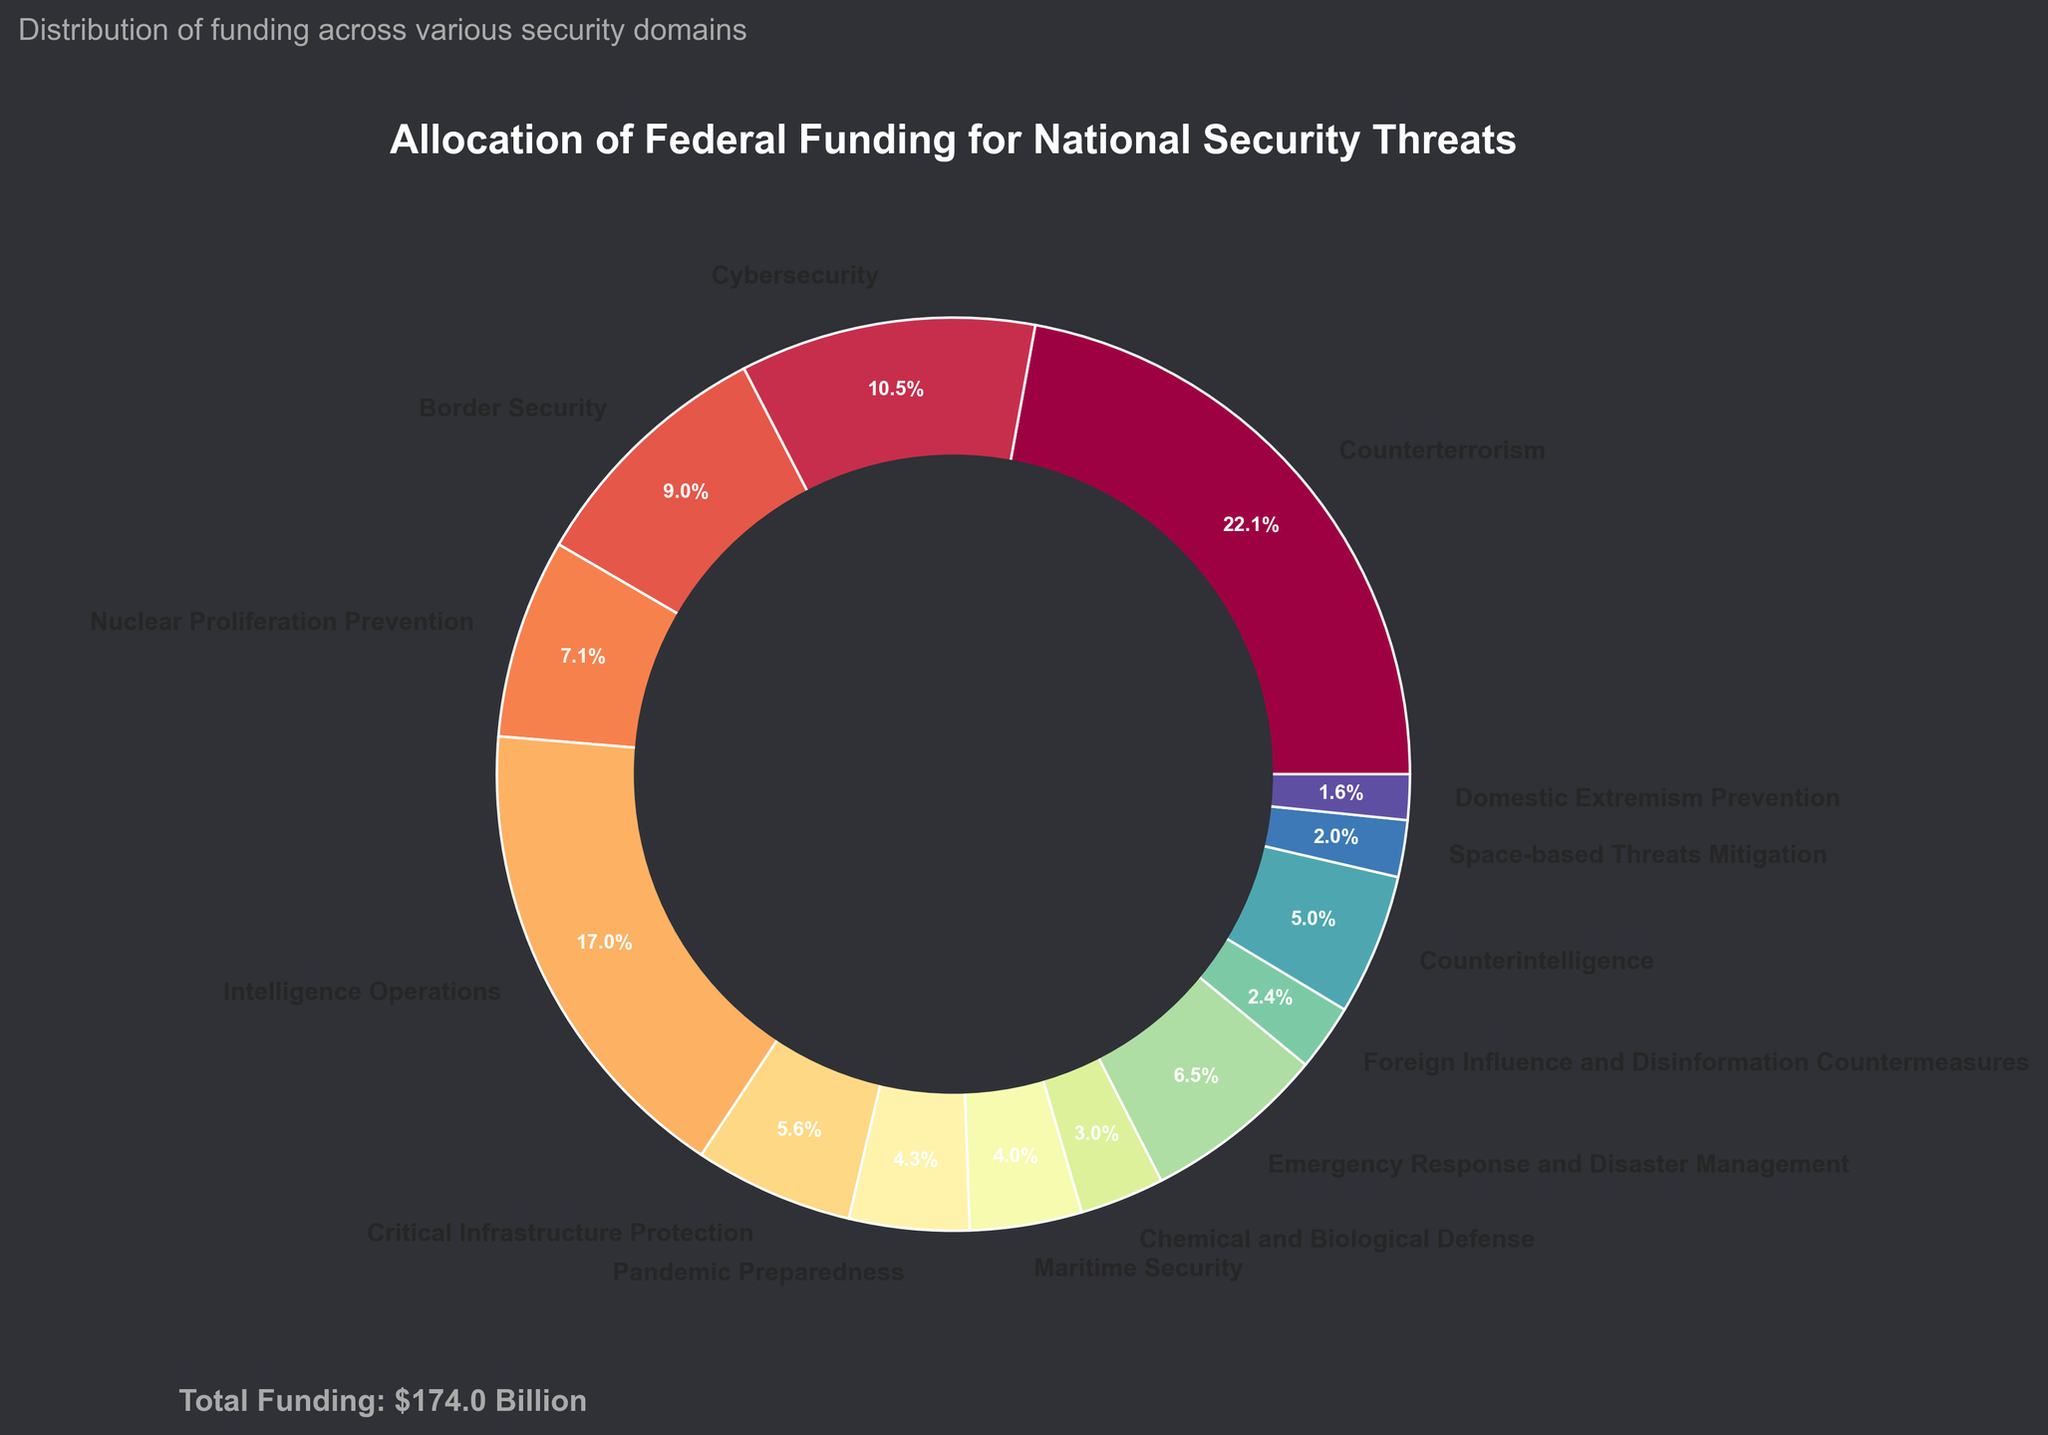Which category receives the highest allocation of federal funding? The category "Counterterrorism" has the largest wedge in the pie chart.
Answer: Counterterrorism Which category receives less funding: Cybersecurity or Border Security? The pie chart shows that "Cybersecurity" has a slightly larger wedge than "Border Security", indicating higher funding.
Answer: Border Security What percentage of the total funding is allocated to Intelligence Operations? The pie chart shows "Intelligence Operations" is labeled with 15.5%, and the corresponding wedge confirms this percentage.
Answer: 15.5% How much more funding is allocated to Counterterrorism compared to Domestic Extremism Prevention? Counterterrorism receives $38.5 billion, while Domestic Extremism Prevention receives $2.8 billion. Subtracting the latter from the former: $38.5B - $2.8B = $35.7B.
Answer: $35.7 billion What's the combined funding for Emergency Response and Disaster Management and Chemical and Biological Defense? Emergency Response and Disaster Management receives $11.3 billion, and Chemical and Biological Defense receives $5.2 billion. Adding these together: $11.3B + $5.2B = $16.5B.
Answer: $16.5 billion Which category has a larger wedge: Critical Infrastructure Protection or Counterintelligence? The pie chart shows "Critical Infrastructure Protection" has a smaller wedge than "Counterintelligence", indicating lesser funding.
Answer: Counterintelligence If you combine the funding for Foreign Influence and Disinformation Countermeasures and Space-based Threats Mitigation, does it exceed $7 billion? Foreign Influence and Disinformation Countermeasures receives $4.1 billion, and Space-based Threats Mitigation receives $3.5 billion. Combining them: $4.1B + $3.5B = $7.6B, which exceeds $7 billion.
Answer: Yes What is the total federal funding allocated for the depicted national security threats? The total funding summation displayed at the bottom of the chart is $174.2 billion.
Answer: $174.2 billion Among the categories receiving below 10% funding, which one has the highest allocation? Among categories with wedges labeled below 10%, "Emergency Response and Disaster Management" has the highest value of $11.3 billion.
Answer: Emergency Response and Disaster Management 